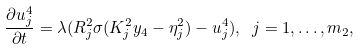Convert formula to latex. <formula><loc_0><loc_0><loc_500><loc_500>\frac { \partial u _ { j } ^ { 4 } } { \partial t } = \lambda ( R _ { j } ^ { 2 } \sigma ( K _ { j } ^ { 2 } y _ { 4 } - \eta _ { j } ^ { 2 } ) - u _ { j } ^ { 4 } ) , \ j = 1 , \dots , m _ { 2 } ,</formula> 